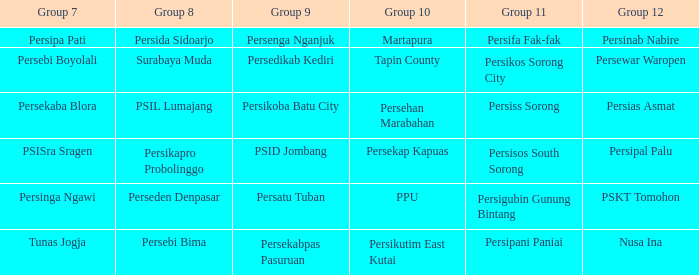Who played in group 8 when Persinab Nabire played in Group 12? Persida Sidoarjo. 